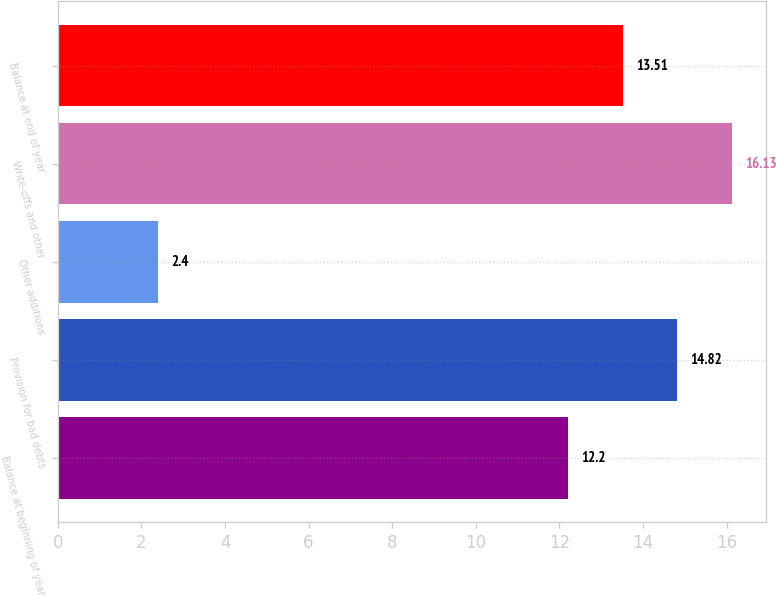Convert chart to OTSL. <chart><loc_0><loc_0><loc_500><loc_500><bar_chart><fcel>Balance at beginning of year<fcel>Provision for bad debts<fcel>Other additions<fcel>Write-offs and other<fcel>Balance at end of year<nl><fcel>12.2<fcel>14.82<fcel>2.4<fcel>16.13<fcel>13.51<nl></chart> 